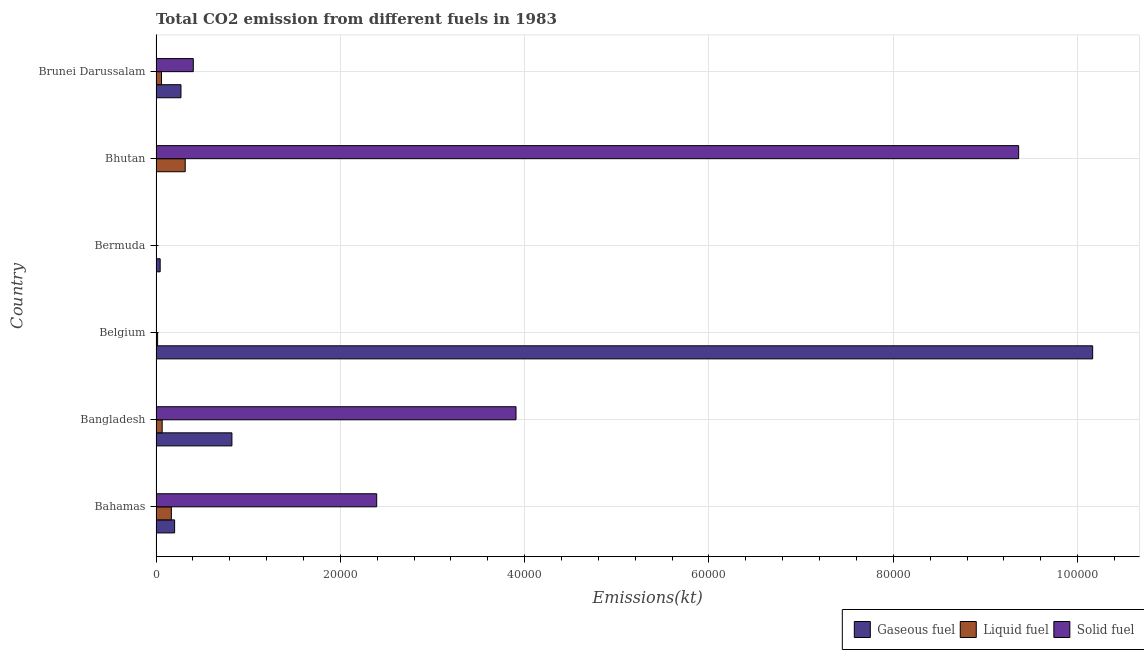How many different coloured bars are there?
Give a very brief answer. 3. How many groups of bars are there?
Keep it short and to the point. 6. How many bars are there on the 2nd tick from the top?
Offer a terse response. 3. What is the label of the 3rd group of bars from the top?
Give a very brief answer. Bermuda. What is the amount of co2 emissions from liquid fuel in Brunei Darussalam?
Provide a short and direct response. 594.05. Across all countries, what is the maximum amount of co2 emissions from gaseous fuel?
Make the answer very short. 1.02e+05. Across all countries, what is the minimum amount of co2 emissions from solid fuel?
Offer a very short reply. 3.67. In which country was the amount of co2 emissions from liquid fuel maximum?
Provide a succinct answer. Bhutan. In which country was the amount of co2 emissions from solid fuel minimum?
Provide a succinct answer. Bermuda. What is the total amount of co2 emissions from gaseous fuel in the graph?
Give a very brief answer. 1.15e+05. What is the difference between the amount of co2 emissions from gaseous fuel in Bahamas and that in Bhutan?
Keep it short and to the point. 1987.51. What is the difference between the amount of co2 emissions from solid fuel in Bangladesh and the amount of co2 emissions from gaseous fuel in Bahamas?
Give a very brief answer. 3.70e+04. What is the average amount of co2 emissions from solid fuel per country?
Provide a short and direct response. 2.68e+04. What is the difference between the amount of co2 emissions from gaseous fuel and amount of co2 emissions from solid fuel in Bangladesh?
Provide a succinct answer. -3.08e+04. In how many countries, is the amount of co2 emissions from solid fuel greater than 100000 kt?
Your answer should be very brief. 0. What is the ratio of the amount of co2 emissions from solid fuel in Bahamas to that in Belgium?
Your answer should be compact. 1306. Is the amount of co2 emissions from liquid fuel in Belgium less than that in Brunei Darussalam?
Give a very brief answer. Yes. Is the difference between the amount of co2 emissions from solid fuel in Bahamas and Brunei Darussalam greater than the difference between the amount of co2 emissions from liquid fuel in Bahamas and Brunei Darussalam?
Offer a very short reply. Yes. What is the difference between the highest and the second highest amount of co2 emissions from solid fuel?
Your answer should be compact. 5.45e+04. What is the difference between the highest and the lowest amount of co2 emissions from solid fuel?
Your answer should be compact. 9.36e+04. Is the sum of the amount of co2 emissions from gaseous fuel in Bangladesh and Bhutan greater than the maximum amount of co2 emissions from liquid fuel across all countries?
Offer a terse response. Yes. What does the 1st bar from the top in Bangladesh represents?
Keep it short and to the point. Solid fuel. What does the 3rd bar from the bottom in Brunei Darussalam represents?
Ensure brevity in your answer.  Solid fuel. Is it the case that in every country, the sum of the amount of co2 emissions from gaseous fuel and amount of co2 emissions from liquid fuel is greater than the amount of co2 emissions from solid fuel?
Make the answer very short. No. How many bars are there?
Your response must be concise. 18. Are the values on the major ticks of X-axis written in scientific E-notation?
Give a very brief answer. No. Does the graph contain any zero values?
Give a very brief answer. No. Does the graph contain grids?
Offer a terse response. Yes. How are the legend labels stacked?
Offer a terse response. Horizontal. What is the title of the graph?
Provide a short and direct response. Total CO2 emission from different fuels in 1983. What is the label or title of the X-axis?
Ensure brevity in your answer.  Emissions(kt). What is the label or title of the Y-axis?
Ensure brevity in your answer.  Country. What is the Emissions(kt) in Gaseous fuel in Bahamas?
Make the answer very short. 2016.85. What is the Emissions(kt) of Liquid fuel in Bahamas?
Ensure brevity in your answer.  1664.82. What is the Emissions(kt) in Solid fuel in Bahamas?
Offer a very short reply. 2.39e+04. What is the Emissions(kt) of Gaseous fuel in Bangladesh?
Ensure brevity in your answer.  8236.08. What is the Emissions(kt) in Liquid fuel in Bangladesh?
Keep it short and to the point. 667.39. What is the Emissions(kt) in Solid fuel in Bangladesh?
Your response must be concise. 3.91e+04. What is the Emissions(kt) in Gaseous fuel in Belgium?
Keep it short and to the point. 1.02e+05. What is the Emissions(kt) of Liquid fuel in Belgium?
Provide a succinct answer. 172.35. What is the Emissions(kt) in Solid fuel in Belgium?
Ensure brevity in your answer.  18.34. What is the Emissions(kt) in Gaseous fuel in Bermuda?
Your answer should be compact. 451.04. What is the Emissions(kt) in Liquid fuel in Bermuda?
Give a very brief answer. 29.34. What is the Emissions(kt) of Solid fuel in Bermuda?
Offer a terse response. 3.67. What is the Emissions(kt) of Gaseous fuel in Bhutan?
Your answer should be compact. 29.34. What is the Emissions(kt) in Liquid fuel in Bhutan?
Make the answer very short. 3168.29. What is the Emissions(kt) in Solid fuel in Bhutan?
Provide a succinct answer. 9.36e+04. What is the Emissions(kt) in Gaseous fuel in Brunei Darussalam?
Offer a very short reply. 2706.25. What is the Emissions(kt) of Liquid fuel in Brunei Darussalam?
Offer a terse response. 594.05. What is the Emissions(kt) in Solid fuel in Brunei Darussalam?
Provide a short and direct response. 4044.7. Across all countries, what is the maximum Emissions(kt) of Gaseous fuel?
Keep it short and to the point. 1.02e+05. Across all countries, what is the maximum Emissions(kt) in Liquid fuel?
Provide a short and direct response. 3168.29. Across all countries, what is the maximum Emissions(kt) of Solid fuel?
Your answer should be compact. 9.36e+04. Across all countries, what is the minimum Emissions(kt) of Gaseous fuel?
Give a very brief answer. 29.34. Across all countries, what is the minimum Emissions(kt) in Liquid fuel?
Your answer should be very brief. 29.34. Across all countries, what is the minimum Emissions(kt) in Solid fuel?
Keep it short and to the point. 3.67. What is the total Emissions(kt) of Gaseous fuel in the graph?
Offer a very short reply. 1.15e+05. What is the total Emissions(kt) in Liquid fuel in the graph?
Give a very brief answer. 6296.24. What is the total Emissions(kt) of Solid fuel in the graph?
Your response must be concise. 1.61e+05. What is the difference between the Emissions(kt) of Gaseous fuel in Bahamas and that in Bangladesh?
Your answer should be very brief. -6219.23. What is the difference between the Emissions(kt) of Liquid fuel in Bahamas and that in Bangladesh?
Keep it short and to the point. 997.42. What is the difference between the Emissions(kt) in Solid fuel in Bahamas and that in Bangladesh?
Your response must be concise. -1.51e+04. What is the difference between the Emissions(kt) in Gaseous fuel in Bahamas and that in Belgium?
Your answer should be compact. -9.96e+04. What is the difference between the Emissions(kt) of Liquid fuel in Bahamas and that in Belgium?
Give a very brief answer. 1492.47. What is the difference between the Emissions(kt) of Solid fuel in Bahamas and that in Belgium?
Give a very brief answer. 2.39e+04. What is the difference between the Emissions(kt) of Gaseous fuel in Bahamas and that in Bermuda?
Provide a short and direct response. 1565.81. What is the difference between the Emissions(kt) of Liquid fuel in Bahamas and that in Bermuda?
Your answer should be compact. 1635.48. What is the difference between the Emissions(kt) in Solid fuel in Bahamas and that in Bermuda?
Make the answer very short. 2.39e+04. What is the difference between the Emissions(kt) of Gaseous fuel in Bahamas and that in Bhutan?
Make the answer very short. 1987.51. What is the difference between the Emissions(kt) in Liquid fuel in Bahamas and that in Bhutan?
Give a very brief answer. -1503.47. What is the difference between the Emissions(kt) in Solid fuel in Bahamas and that in Bhutan?
Your answer should be very brief. -6.97e+04. What is the difference between the Emissions(kt) in Gaseous fuel in Bahamas and that in Brunei Darussalam?
Your answer should be very brief. -689.4. What is the difference between the Emissions(kt) of Liquid fuel in Bahamas and that in Brunei Darussalam?
Offer a very short reply. 1070.76. What is the difference between the Emissions(kt) in Solid fuel in Bahamas and that in Brunei Darussalam?
Give a very brief answer. 1.99e+04. What is the difference between the Emissions(kt) in Gaseous fuel in Bangladesh and that in Belgium?
Your response must be concise. -9.34e+04. What is the difference between the Emissions(kt) of Liquid fuel in Bangladesh and that in Belgium?
Provide a succinct answer. 495.05. What is the difference between the Emissions(kt) of Solid fuel in Bangladesh and that in Belgium?
Make the answer very short. 3.90e+04. What is the difference between the Emissions(kt) of Gaseous fuel in Bangladesh and that in Bermuda?
Provide a short and direct response. 7785.04. What is the difference between the Emissions(kt) of Liquid fuel in Bangladesh and that in Bermuda?
Ensure brevity in your answer.  638.06. What is the difference between the Emissions(kt) in Solid fuel in Bangladesh and that in Bermuda?
Your answer should be compact. 3.91e+04. What is the difference between the Emissions(kt) of Gaseous fuel in Bangladesh and that in Bhutan?
Provide a short and direct response. 8206.75. What is the difference between the Emissions(kt) in Liquid fuel in Bangladesh and that in Bhutan?
Your response must be concise. -2500.89. What is the difference between the Emissions(kt) in Solid fuel in Bangladesh and that in Bhutan?
Provide a short and direct response. -5.45e+04. What is the difference between the Emissions(kt) in Gaseous fuel in Bangladesh and that in Brunei Darussalam?
Give a very brief answer. 5529.84. What is the difference between the Emissions(kt) of Liquid fuel in Bangladesh and that in Brunei Darussalam?
Your answer should be compact. 73.34. What is the difference between the Emissions(kt) in Solid fuel in Bangladesh and that in Brunei Darussalam?
Your answer should be compact. 3.50e+04. What is the difference between the Emissions(kt) of Gaseous fuel in Belgium and that in Bermuda?
Offer a terse response. 1.01e+05. What is the difference between the Emissions(kt) of Liquid fuel in Belgium and that in Bermuda?
Your answer should be compact. 143.01. What is the difference between the Emissions(kt) of Solid fuel in Belgium and that in Bermuda?
Offer a very short reply. 14.67. What is the difference between the Emissions(kt) in Gaseous fuel in Belgium and that in Bhutan?
Your answer should be very brief. 1.02e+05. What is the difference between the Emissions(kt) of Liquid fuel in Belgium and that in Bhutan?
Your answer should be compact. -2995.94. What is the difference between the Emissions(kt) in Solid fuel in Belgium and that in Bhutan?
Keep it short and to the point. -9.36e+04. What is the difference between the Emissions(kt) in Gaseous fuel in Belgium and that in Brunei Darussalam?
Give a very brief answer. 9.89e+04. What is the difference between the Emissions(kt) of Liquid fuel in Belgium and that in Brunei Darussalam?
Make the answer very short. -421.7. What is the difference between the Emissions(kt) in Solid fuel in Belgium and that in Brunei Darussalam?
Provide a succinct answer. -4026.37. What is the difference between the Emissions(kt) in Gaseous fuel in Bermuda and that in Bhutan?
Provide a short and direct response. 421.7. What is the difference between the Emissions(kt) in Liquid fuel in Bermuda and that in Bhutan?
Provide a succinct answer. -3138.95. What is the difference between the Emissions(kt) of Solid fuel in Bermuda and that in Bhutan?
Provide a short and direct response. -9.36e+04. What is the difference between the Emissions(kt) of Gaseous fuel in Bermuda and that in Brunei Darussalam?
Give a very brief answer. -2255.2. What is the difference between the Emissions(kt) in Liquid fuel in Bermuda and that in Brunei Darussalam?
Offer a terse response. -564.72. What is the difference between the Emissions(kt) in Solid fuel in Bermuda and that in Brunei Darussalam?
Provide a short and direct response. -4041.03. What is the difference between the Emissions(kt) in Gaseous fuel in Bhutan and that in Brunei Darussalam?
Give a very brief answer. -2676.91. What is the difference between the Emissions(kt) of Liquid fuel in Bhutan and that in Brunei Darussalam?
Ensure brevity in your answer.  2574.23. What is the difference between the Emissions(kt) in Solid fuel in Bhutan and that in Brunei Darussalam?
Your answer should be very brief. 8.96e+04. What is the difference between the Emissions(kt) of Gaseous fuel in Bahamas and the Emissions(kt) of Liquid fuel in Bangladesh?
Offer a very short reply. 1349.46. What is the difference between the Emissions(kt) of Gaseous fuel in Bahamas and the Emissions(kt) of Solid fuel in Bangladesh?
Ensure brevity in your answer.  -3.70e+04. What is the difference between the Emissions(kt) in Liquid fuel in Bahamas and the Emissions(kt) in Solid fuel in Bangladesh?
Provide a succinct answer. -3.74e+04. What is the difference between the Emissions(kt) in Gaseous fuel in Bahamas and the Emissions(kt) in Liquid fuel in Belgium?
Make the answer very short. 1844.5. What is the difference between the Emissions(kt) of Gaseous fuel in Bahamas and the Emissions(kt) of Solid fuel in Belgium?
Give a very brief answer. 1998.52. What is the difference between the Emissions(kt) of Liquid fuel in Bahamas and the Emissions(kt) of Solid fuel in Belgium?
Offer a terse response. 1646.48. What is the difference between the Emissions(kt) in Gaseous fuel in Bahamas and the Emissions(kt) in Liquid fuel in Bermuda?
Offer a very short reply. 1987.51. What is the difference between the Emissions(kt) of Gaseous fuel in Bahamas and the Emissions(kt) of Solid fuel in Bermuda?
Ensure brevity in your answer.  2013.18. What is the difference between the Emissions(kt) of Liquid fuel in Bahamas and the Emissions(kt) of Solid fuel in Bermuda?
Offer a very short reply. 1661.15. What is the difference between the Emissions(kt) in Gaseous fuel in Bahamas and the Emissions(kt) in Liquid fuel in Bhutan?
Provide a short and direct response. -1151.44. What is the difference between the Emissions(kt) of Gaseous fuel in Bahamas and the Emissions(kt) of Solid fuel in Bhutan?
Your answer should be very brief. -9.16e+04. What is the difference between the Emissions(kt) of Liquid fuel in Bahamas and the Emissions(kt) of Solid fuel in Bhutan?
Offer a terse response. -9.19e+04. What is the difference between the Emissions(kt) of Gaseous fuel in Bahamas and the Emissions(kt) of Liquid fuel in Brunei Darussalam?
Keep it short and to the point. 1422.8. What is the difference between the Emissions(kt) of Gaseous fuel in Bahamas and the Emissions(kt) of Solid fuel in Brunei Darussalam?
Your answer should be very brief. -2027.85. What is the difference between the Emissions(kt) of Liquid fuel in Bahamas and the Emissions(kt) of Solid fuel in Brunei Darussalam?
Provide a succinct answer. -2379.88. What is the difference between the Emissions(kt) in Gaseous fuel in Bangladesh and the Emissions(kt) in Liquid fuel in Belgium?
Your answer should be compact. 8063.73. What is the difference between the Emissions(kt) of Gaseous fuel in Bangladesh and the Emissions(kt) of Solid fuel in Belgium?
Provide a short and direct response. 8217.75. What is the difference between the Emissions(kt) in Liquid fuel in Bangladesh and the Emissions(kt) in Solid fuel in Belgium?
Your answer should be very brief. 649.06. What is the difference between the Emissions(kt) of Gaseous fuel in Bangladesh and the Emissions(kt) of Liquid fuel in Bermuda?
Provide a short and direct response. 8206.75. What is the difference between the Emissions(kt) in Gaseous fuel in Bangladesh and the Emissions(kt) in Solid fuel in Bermuda?
Make the answer very short. 8232.42. What is the difference between the Emissions(kt) in Liquid fuel in Bangladesh and the Emissions(kt) in Solid fuel in Bermuda?
Ensure brevity in your answer.  663.73. What is the difference between the Emissions(kt) in Gaseous fuel in Bangladesh and the Emissions(kt) in Liquid fuel in Bhutan?
Make the answer very short. 5067.79. What is the difference between the Emissions(kt) in Gaseous fuel in Bangladesh and the Emissions(kt) in Solid fuel in Bhutan?
Your answer should be compact. -8.54e+04. What is the difference between the Emissions(kt) of Liquid fuel in Bangladesh and the Emissions(kt) of Solid fuel in Bhutan?
Give a very brief answer. -9.29e+04. What is the difference between the Emissions(kt) of Gaseous fuel in Bangladesh and the Emissions(kt) of Liquid fuel in Brunei Darussalam?
Ensure brevity in your answer.  7642.03. What is the difference between the Emissions(kt) of Gaseous fuel in Bangladesh and the Emissions(kt) of Solid fuel in Brunei Darussalam?
Make the answer very short. 4191.38. What is the difference between the Emissions(kt) of Liquid fuel in Bangladesh and the Emissions(kt) of Solid fuel in Brunei Darussalam?
Make the answer very short. -3377.31. What is the difference between the Emissions(kt) in Gaseous fuel in Belgium and the Emissions(kt) in Liquid fuel in Bermuda?
Keep it short and to the point. 1.02e+05. What is the difference between the Emissions(kt) in Gaseous fuel in Belgium and the Emissions(kt) in Solid fuel in Bermuda?
Provide a short and direct response. 1.02e+05. What is the difference between the Emissions(kt) of Liquid fuel in Belgium and the Emissions(kt) of Solid fuel in Bermuda?
Provide a succinct answer. 168.68. What is the difference between the Emissions(kt) of Gaseous fuel in Belgium and the Emissions(kt) of Liquid fuel in Bhutan?
Offer a very short reply. 9.85e+04. What is the difference between the Emissions(kt) in Gaseous fuel in Belgium and the Emissions(kt) in Solid fuel in Bhutan?
Make the answer very short. 8030.73. What is the difference between the Emissions(kt) of Liquid fuel in Belgium and the Emissions(kt) of Solid fuel in Bhutan?
Provide a succinct answer. -9.34e+04. What is the difference between the Emissions(kt) of Gaseous fuel in Belgium and the Emissions(kt) of Liquid fuel in Brunei Darussalam?
Provide a short and direct response. 1.01e+05. What is the difference between the Emissions(kt) in Gaseous fuel in Belgium and the Emissions(kt) in Solid fuel in Brunei Darussalam?
Give a very brief answer. 9.76e+04. What is the difference between the Emissions(kt) in Liquid fuel in Belgium and the Emissions(kt) in Solid fuel in Brunei Darussalam?
Keep it short and to the point. -3872.35. What is the difference between the Emissions(kt) in Gaseous fuel in Bermuda and the Emissions(kt) in Liquid fuel in Bhutan?
Provide a succinct answer. -2717.25. What is the difference between the Emissions(kt) of Gaseous fuel in Bermuda and the Emissions(kt) of Solid fuel in Bhutan?
Offer a terse response. -9.31e+04. What is the difference between the Emissions(kt) in Liquid fuel in Bermuda and the Emissions(kt) in Solid fuel in Bhutan?
Ensure brevity in your answer.  -9.36e+04. What is the difference between the Emissions(kt) in Gaseous fuel in Bermuda and the Emissions(kt) in Liquid fuel in Brunei Darussalam?
Your answer should be very brief. -143.01. What is the difference between the Emissions(kt) of Gaseous fuel in Bermuda and the Emissions(kt) of Solid fuel in Brunei Darussalam?
Keep it short and to the point. -3593.66. What is the difference between the Emissions(kt) of Liquid fuel in Bermuda and the Emissions(kt) of Solid fuel in Brunei Darussalam?
Ensure brevity in your answer.  -4015.36. What is the difference between the Emissions(kt) of Gaseous fuel in Bhutan and the Emissions(kt) of Liquid fuel in Brunei Darussalam?
Keep it short and to the point. -564.72. What is the difference between the Emissions(kt) in Gaseous fuel in Bhutan and the Emissions(kt) in Solid fuel in Brunei Darussalam?
Keep it short and to the point. -4015.36. What is the difference between the Emissions(kt) in Liquid fuel in Bhutan and the Emissions(kt) in Solid fuel in Brunei Darussalam?
Give a very brief answer. -876.41. What is the average Emissions(kt) in Gaseous fuel per country?
Keep it short and to the point. 1.92e+04. What is the average Emissions(kt) in Liquid fuel per country?
Your answer should be compact. 1049.37. What is the average Emissions(kt) of Solid fuel per country?
Offer a very short reply. 2.68e+04. What is the difference between the Emissions(kt) of Gaseous fuel and Emissions(kt) of Liquid fuel in Bahamas?
Provide a short and direct response. 352.03. What is the difference between the Emissions(kt) of Gaseous fuel and Emissions(kt) of Solid fuel in Bahamas?
Give a very brief answer. -2.19e+04. What is the difference between the Emissions(kt) in Liquid fuel and Emissions(kt) in Solid fuel in Bahamas?
Provide a short and direct response. -2.23e+04. What is the difference between the Emissions(kt) of Gaseous fuel and Emissions(kt) of Liquid fuel in Bangladesh?
Make the answer very short. 7568.69. What is the difference between the Emissions(kt) in Gaseous fuel and Emissions(kt) in Solid fuel in Bangladesh?
Your answer should be compact. -3.08e+04. What is the difference between the Emissions(kt) in Liquid fuel and Emissions(kt) in Solid fuel in Bangladesh?
Give a very brief answer. -3.84e+04. What is the difference between the Emissions(kt) of Gaseous fuel and Emissions(kt) of Liquid fuel in Belgium?
Your answer should be compact. 1.01e+05. What is the difference between the Emissions(kt) in Gaseous fuel and Emissions(kt) in Solid fuel in Belgium?
Ensure brevity in your answer.  1.02e+05. What is the difference between the Emissions(kt) of Liquid fuel and Emissions(kt) of Solid fuel in Belgium?
Offer a very short reply. 154.01. What is the difference between the Emissions(kt) in Gaseous fuel and Emissions(kt) in Liquid fuel in Bermuda?
Offer a very short reply. 421.7. What is the difference between the Emissions(kt) of Gaseous fuel and Emissions(kt) of Solid fuel in Bermuda?
Provide a succinct answer. 447.37. What is the difference between the Emissions(kt) of Liquid fuel and Emissions(kt) of Solid fuel in Bermuda?
Keep it short and to the point. 25.67. What is the difference between the Emissions(kt) in Gaseous fuel and Emissions(kt) in Liquid fuel in Bhutan?
Offer a terse response. -3138.95. What is the difference between the Emissions(kt) of Gaseous fuel and Emissions(kt) of Solid fuel in Bhutan?
Make the answer very short. -9.36e+04. What is the difference between the Emissions(kt) in Liquid fuel and Emissions(kt) in Solid fuel in Bhutan?
Offer a terse response. -9.04e+04. What is the difference between the Emissions(kt) in Gaseous fuel and Emissions(kt) in Liquid fuel in Brunei Darussalam?
Offer a very short reply. 2112.19. What is the difference between the Emissions(kt) in Gaseous fuel and Emissions(kt) in Solid fuel in Brunei Darussalam?
Offer a terse response. -1338.45. What is the difference between the Emissions(kt) of Liquid fuel and Emissions(kt) of Solid fuel in Brunei Darussalam?
Ensure brevity in your answer.  -3450.65. What is the ratio of the Emissions(kt) in Gaseous fuel in Bahamas to that in Bangladesh?
Ensure brevity in your answer.  0.24. What is the ratio of the Emissions(kt) in Liquid fuel in Bahamas to that in Bangladesh?
Offer a terse response. 2.49. What is the ratio of the Emissions(kt) of Solid fuel in Bahamas to that in Bangladesh?
Your response must be concise. 0.61. What is the ratio of the Emissions(kt) in Gaseous fuel in Bahamas to that in Belgium?
Offer a terse response. 0.02. What is the ratio of the Emissions(kt) in Liquid fuel in Bahamas to that in Belgium?
Your answer should be compact. 9.66. What is the ratio of the Emissions(kt) of Solid fuel in Bahamas to that in Belgium?
Your answer should be compact. 1306. What is the ratio of the Emissions(kt) of Gaseous fuel in Bahamas to that in Bermuda?
Give a very brief answer. 4.47. What is the ratio of the Emissions(kt) of Liquid fuel in Bahamas to that in Bermuda?
Your answer should be very brief. 56.75. What is the ratio of the Emissions(kt) of Solid fuel in Bahamas to that in Bermuda?
Make the answer very short. 6530. What is the ratio of the Emissions(kt) of Gaseous fuel in Bahamas to that in Bhutan?
Offer a terse response. 68.75. What is the ratio of the Emissions(kt) in Liquid fuel in Bahamas to that in Bhutan?
Offer a very short reply. 0.53. What is the ratio of the Emissions(kt) in Solid fuel in Bahamas to that in Bhutan?
Give a very brief answer. 0.26. What is the ratio of the Emissions(kt) of Gaseous fuel in Bahamas to that in Brunei Darussalam?
Keep it short and to the point. 0.75. What is the ratio of the Emissions(kt) of Liquid fuel in Bahamas to that in Brunei Darussalam?
Give a very brief answer. 2.8. What is the ratio of the Emissions(kt) of Solid fuel in Bahamas to that in Brunei Darussalam?
Keep it short and to the point. 5.92. What is the ratio of the Emissions(kt) in Gaseous fuel in Bangladesh to that in Belgium?
Provide a short and direct response. 0.08. What is the ratio of the Emissions(kt) in Liquid fuel in Bangladesh to that in Belgium?
Keep it short and to the point. 3.87. What is the ratio of the Emissions(kt) of Solid fuel in Bangladesh to that in Belgium?
Keep it short and to the point. 2130.4. What is the ratio of the Emissions(kt) of Gaseous fuel in Bangladesh to that in Bermuda?
Keep it short and to the point. 18.26. What is the ratio of the Emissions(kt) of Liquid fuel in Bangladesh to that in Bermuda?
Your answer should be compact. 22.75. What is the ratio of the Emissions(kt) of Solid fuel in Bangladesh to that in Bermuda?
Your response must be concise. 1.07e+04. What is the ratio of the Emissions(kt) in Gaseous fuel in Bangladesh to that in Bhutan?
Offer a terse response. 280.75. What is the ratio of the Emissions(kt) in Liquid fuel in Bangladesh to that in Bhutan?
Your response must be concise. 0.21. What is the ratio of the Emissions(kt) of Solid fuel in Bangladesh to that in Bhutan?
Keep it short and to the point. 0.42. What is the ratio of the Emissions(kt) in Gaseous fuel in Bangladesh to that in Brunei Darussalam?
Offer a terse response. 3.04. What is the ratio of the Emissions(kt) in Liquid fuel in Bangladesh to that in Brunei Darussalam?
Provide a succinct answer. 1.12. What is the ratio of the Emissions(kt) in Solid fuel in Bangladesh to that in Brunei Darussalam?
Make the answer very short. 9.66. What is the ratio of the Emissions(kt) in Gaseous fuel in Belgium to that in Bermuda?
Your answer should be very brief. 225.33. What is the ratio of the Emissions(kt) in Liquid fuel in Belgium to that in Bermuda?
Offer a very short reply. 5.88. What is the ratio of the Emissions(kt) of Gaseous fuel in Belgium to that in Bhutan?
Give a very brief answer. 3464.38. What is the ratio of the Emissions(kt) of Liquid fuel in Belgium to that in Bhutan?
Your answer should be compact. 0.05. What is the ratio of the Emissions(kt) in Solid fuel in Belgium to that in Bhutan?
Ensure brevity in your answer.  0. What is the ratio of the Emissions(kt) in Gaseous fuel in Belgium to that in Brunei Darussalam?
Keep it short and to the point. 37.55. What is the ratio of the Emissions(kt) in Liquid fuel in Belgium to that in Brunei Darussalam?
Keep it short and to the point. 0.29. What is the ratio of the Emissions(kt) of Solid fuel in Belgium to that in Brunei Darussalam?
Keep it short and to the point. 0. What is the ratio of the Emissions(kt) in Gaseous fuel in Bermuda to that in Bhutan?
Provide a short and direct response. 15.38. What is the ratio of the Emissions(kt) in Liquid fuel in Bermuda to that in Bhutan?
Give a very brief answer. 0.01. What is the ratio of the Emissions(kt) of Solid fuel in Bermuda to that in Bhutan?
Make the answer very short. 0. What is the ratio of the Emissions(kt) of Gaseous fuel in Bermuda to that in Brunei Darussalam?
Your answer should be compact. 0.17. What is the ratio of the Emissions(kt) in Liquid fuel in Bermuda to that in Brunei Darussalam?
Your answer should be very brief. 0.05. What is the ratio of the Emissions(kt) in Solid fuel in Bermuda to that in Brunei Darussalam?
Ensure brevity in your answer.  0. What is the ratio of the Emissions(kt) of Gaseous fuel in Bhutan to that in Brunei Darussalam?
Give a very brief answer. 0.01. What is the ratio of the Emissions(kt) in Liquid fuel in Bhutan to that in Brunei Darussalam?
Your answer should be compact. 5.33. What is the ratio of the Emissions(kt) of Solid fuel in Bhutan to that in Brunei Darussalam?
Your answer should be very brief. 23.14. What is the difference between the highest and the second highest Emissions(kt) in Gaseous fuel?
Provide a short and direct response. 9.34e+04. What is the difference between the highest and the second highest Emissions(kt) in Liquid fuel?
Provide a short and direct response. 1503.47. What is the difference between the highest and the second highest Emissions(kt) in Solid fuel?
Make the answer very short. 5.45e+04. What is the difference between the highest and the lowest Emissions(kt) of Gaseous fuel?
Keep it short and to the point. 1.02e+05. What is the difference between the highest and the lowest Emissions(kt) of Liquid fuel?
Provide a succinct answer. 3138.95. What is the difference between the highest and the lowest Emissions(kt) of Solid fuel?
Your response must be concise. 9.36e+04. 